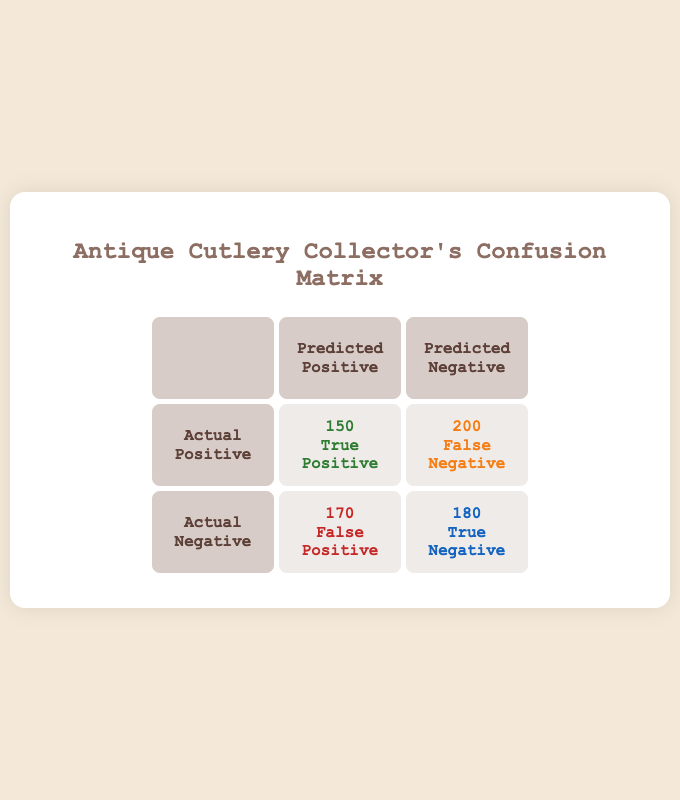What is the number of True Positives in the confusion matrix? The confusion matrix states that the True Positives are 150. This is directly taken from the cell labeled "True Positive" in the table.
Answer: 150 How many False Negatives were recorded? The confusion matrix indicates that the False Negatives are 200. This value can be found in the cell labeled "False Negative" in the table.
Answer: 200 What is the total number of predicted positives? The total number of predicted positives is calculated by adding True Positives and False Positives. This equals 150 + 170 = 320.
Answer: 320 What is the total number of actual positives in the confusion matrix? The total number of actual positives can be found by adding True Positives and False Negatives. This results in 150 + 200 = 350.
Answer: 350 Is the number of True Negatives greater than 150? The confusion matrix shows that there are 180 True Negatives. Since 180 is greater than 150, the answer is true.
Answer: Yes How many more False Positives are there than True Positives? To find this, we subtract True Positives from False Positives: 170 - 150 = 20. This means there are 20 more False Positives than True Positives.
Answer: 20 What percentage of collectors were correctly classified as positives? To find the percentage, divide True Positives by the total actual positives and multiply by 100: (150 / 350) * 100 = 42.86%. Thus, about 42.86% of collectors were correctly classified as positives.
Answer: 42.86% If the number of collectors in the Northeast is 200, how does it compare to the number of sales in that region? The Northeast has 200 collectors and 150 sales. Since 150 is less than 200, it indicates that the number of sales is lower than the number of collectors.
Answer: Sales are lower What is the ratio of True Negatives to False Negatives? To calculate the ratio of True Negatives to False Negatives, we divide True Negatives (180) by False Negatives (200), which gives 180:200 or simplified, 9:10.
Answer: 9:10 